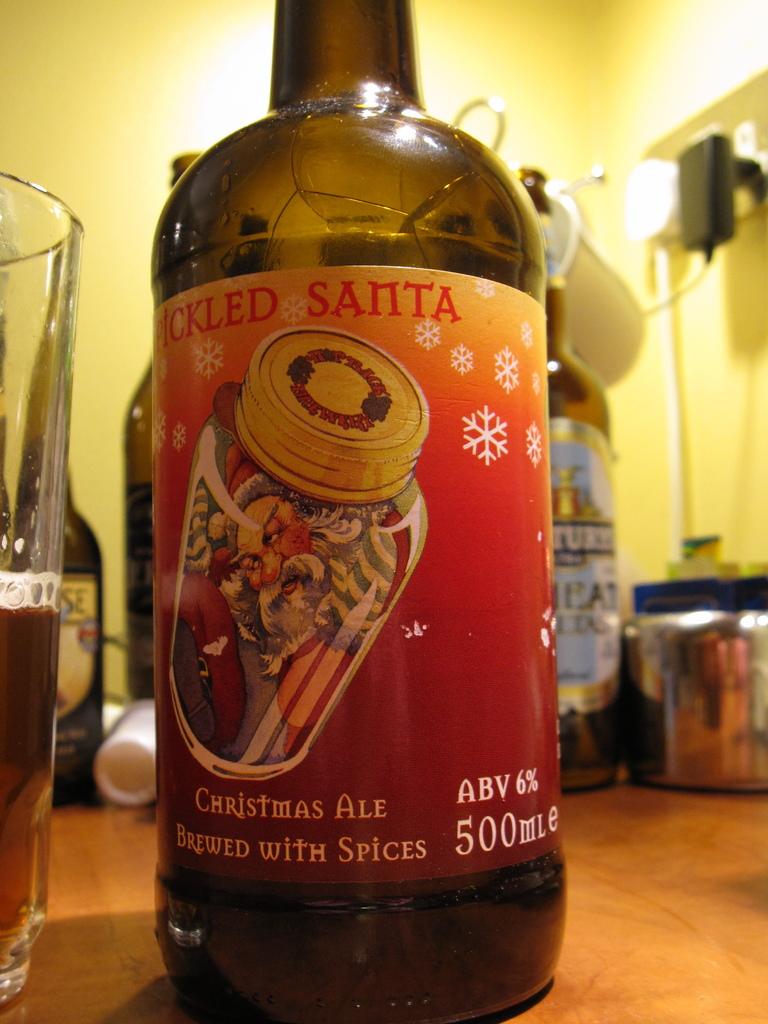How many ml?
Give a very brief answer. 500. What is the name of th ale?
Keep it short and to the point. Pickled santa. 